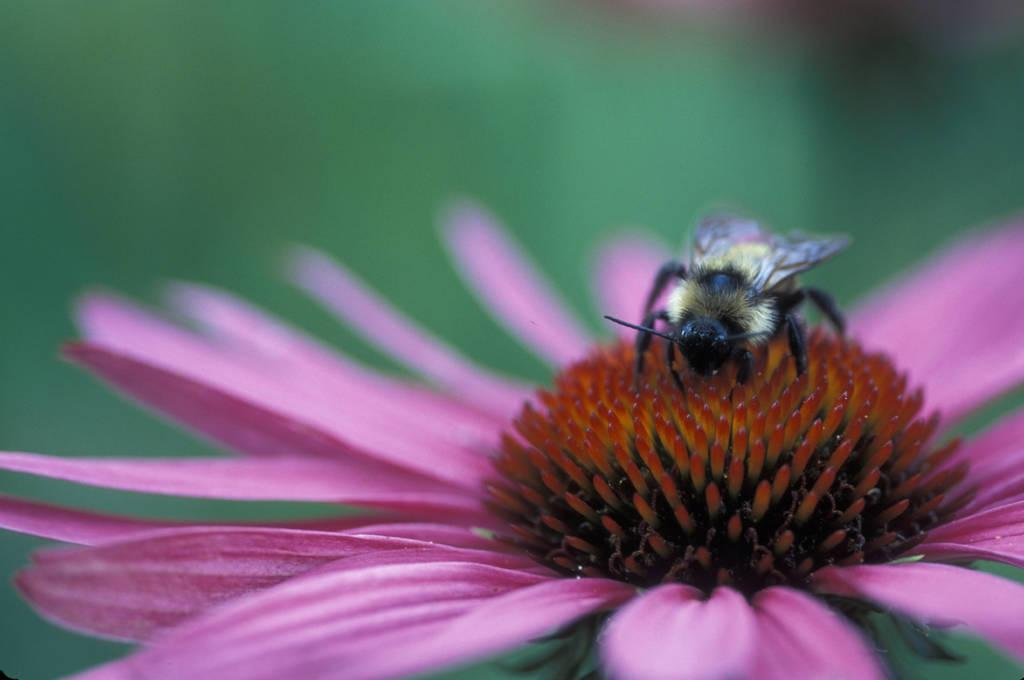What is present in the image? There is a bee in the image. Where is the bee located? The bee is on a pink flower. What type of gold object is the bee carrying in the image? There is no gold object present in the image; the bee is simply on a pink flower. 